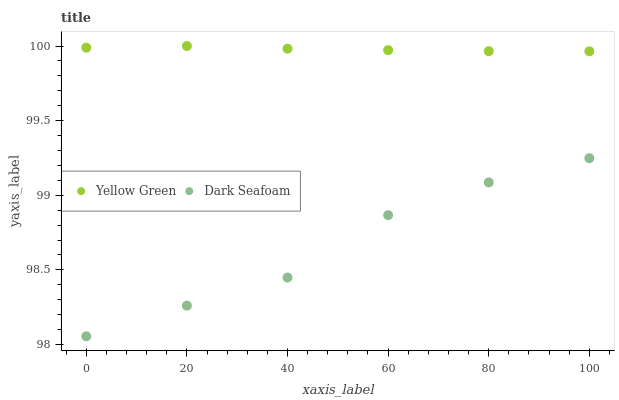Does Dark Seafoam have the minimum area under the curve?
Answer yes or no. Yes. Does Yellow Green have the maximum area under the curve?
Answer yes or no. Yes. Does Yellow Green have the minimum area under the curve?
Answer yes or no. No. Is Yellow Green the smoothest?
Answer yes or no. Yes. Is Dark Seafoam the roughest?
Answer yes or no. Yes. Is Yellow Green the roughest?
Answer yes or no. No. Does Dark Seafoam have the lowest value?
Answer yes or no. Yes. Does Yellow Green have the lowest value?
Answer yes or no. No. Does Yellow Green have the highest value?
Answer yes or no. Yes. Is Dark Seafoam less than Yellow Green?
Answer yes or no. Yes. Is Yellow Green greater than Dark Seafoam?
Answer yes or no. Yes. Does Dark Seafoam intersect Yellow Green?
Answer yes or no. No. 